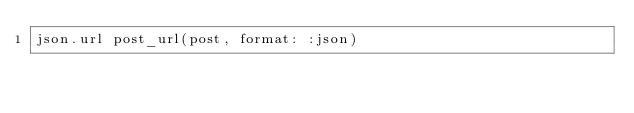Convert code to text. <code><loc_0><loc_0><loc_500><loc_500><_Ruby_>json.url post_url(post, format: :json)</code> 